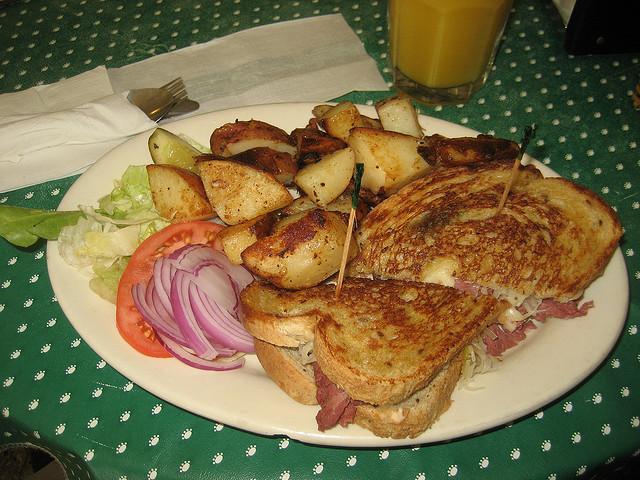Is there a bowl of beans on the plate?
Keep it brief. No. What is in the cup on the table?
Short answer required. Orange juice. What is the type of food placed on the plate?
Answer briefly. Lunch. What beverage is in the glass?
Write a very short answer. Orange juice. How many different food groups are on the plate?
Give a very brief answer. 3. Is this before or after dinner?
Be succinct. Before. What color is the onion?
Short answer required. Purple. What kind of bread is that?
Answer briefly. Rye. Is there cantaloupe in this photo?
Write a very short answer. No. What color is the plate?
Give a very brief answer. White. How many fries on the plate?
Keep it brief. 0. How many calories are in this meal?
Quick response, please. 2500. What type of juice is in the glass?
Be succinct. Orange. Has the sandwich been eaten yet?
Concise answer only. No. What sides are on the dinner plate?
Quick response, please. Potatoes. What is the green object?
Quick response, please. Lettuce. What kind of potato are they having?
Short answer required. Fried. 